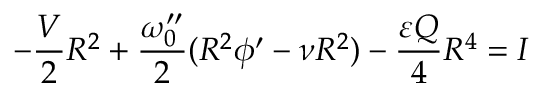Convert formula to latex. <formula><loc_0><loc_0><loc_500><loc_500>- \frac { V } { 2 } R ^ { 2 } + \frac { \omega _ { 0 } ^ { \prime \prime } } { 2 } ( R ^ { 2 } \phi ^ { \prime } - \nu R ^ { 2 } ) - \frac { \varepsilon Q } { 4 } R ^ { 4 } = I</formula> 